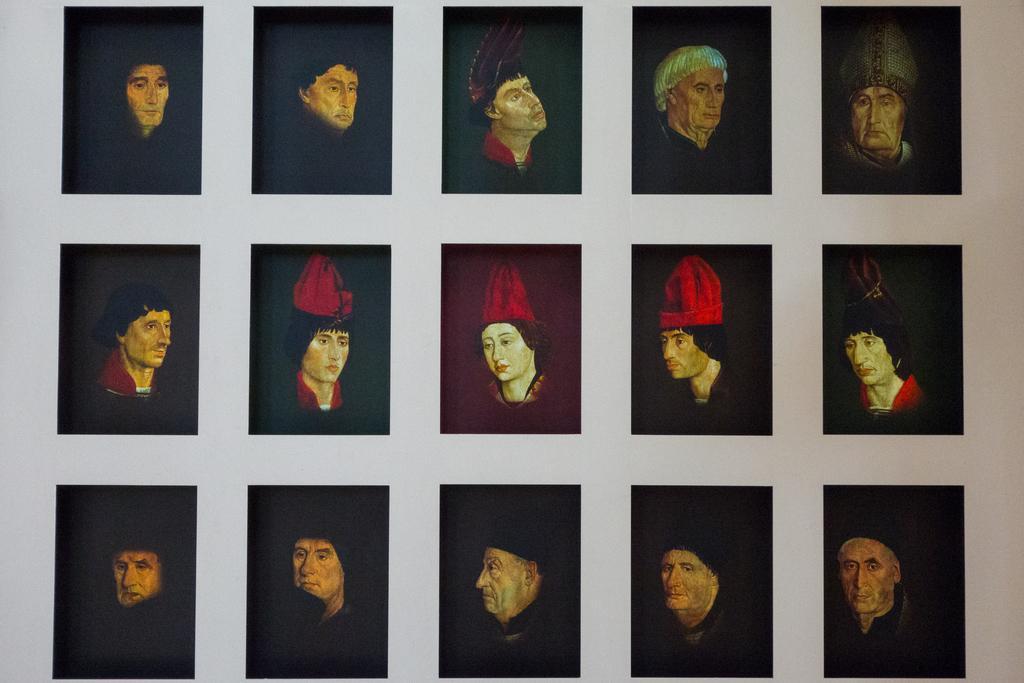Could you give a brief overview of what you see in this image? In this picture I can see many painting on the black cloth which are placed on the wall. 